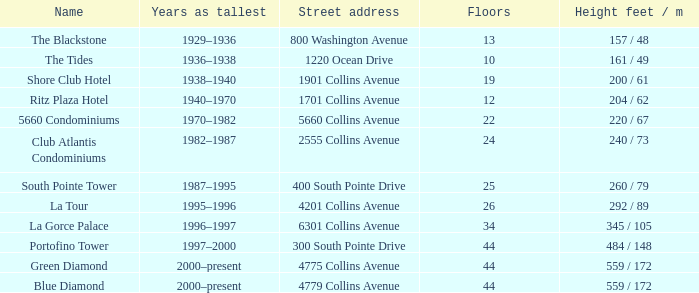What is the altitude of the tides with less than 34 levels? 161 / 49. 